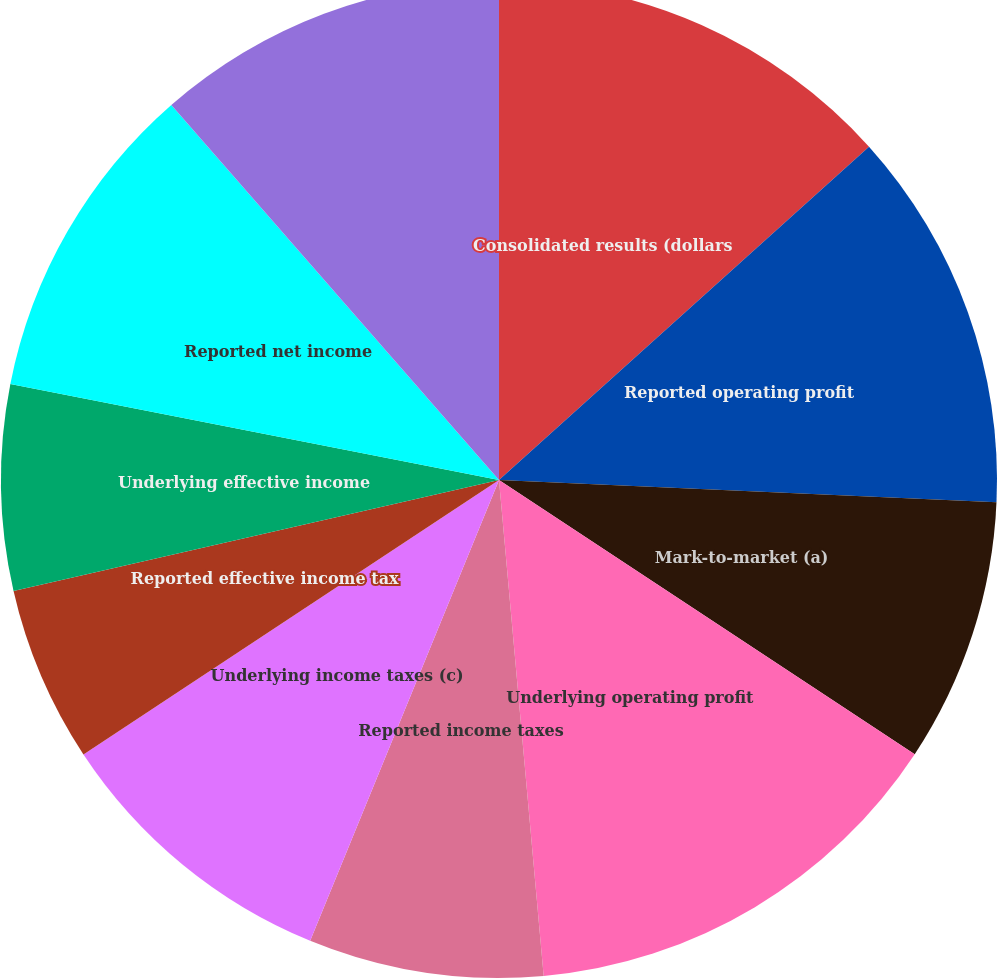Convert chart. <chart><loc_0><loc_0><loc_500><loc_500><pie_chart><fcel>Consolidated results (dollars<fcel>Reported operating profit<fcel>Mark-to-market (a)<fcel>Underlying operating profit<fcel>Reported income taxes<fcel>Underlying income taxes (c)<fcel>Reported effective income tax<fcel>Underlying effective income<fcel>Reported net income<fcel>Underlying net income<nl><fcel>13.33%<fcel>12.38%<fcel>8.57%<fcel>14.29%<fcel>7.62%<fcel>9.52%<fcel>5.71%<fcel>6.67%<fcel>10.48%<fcel>11.43%<nl></chart> 